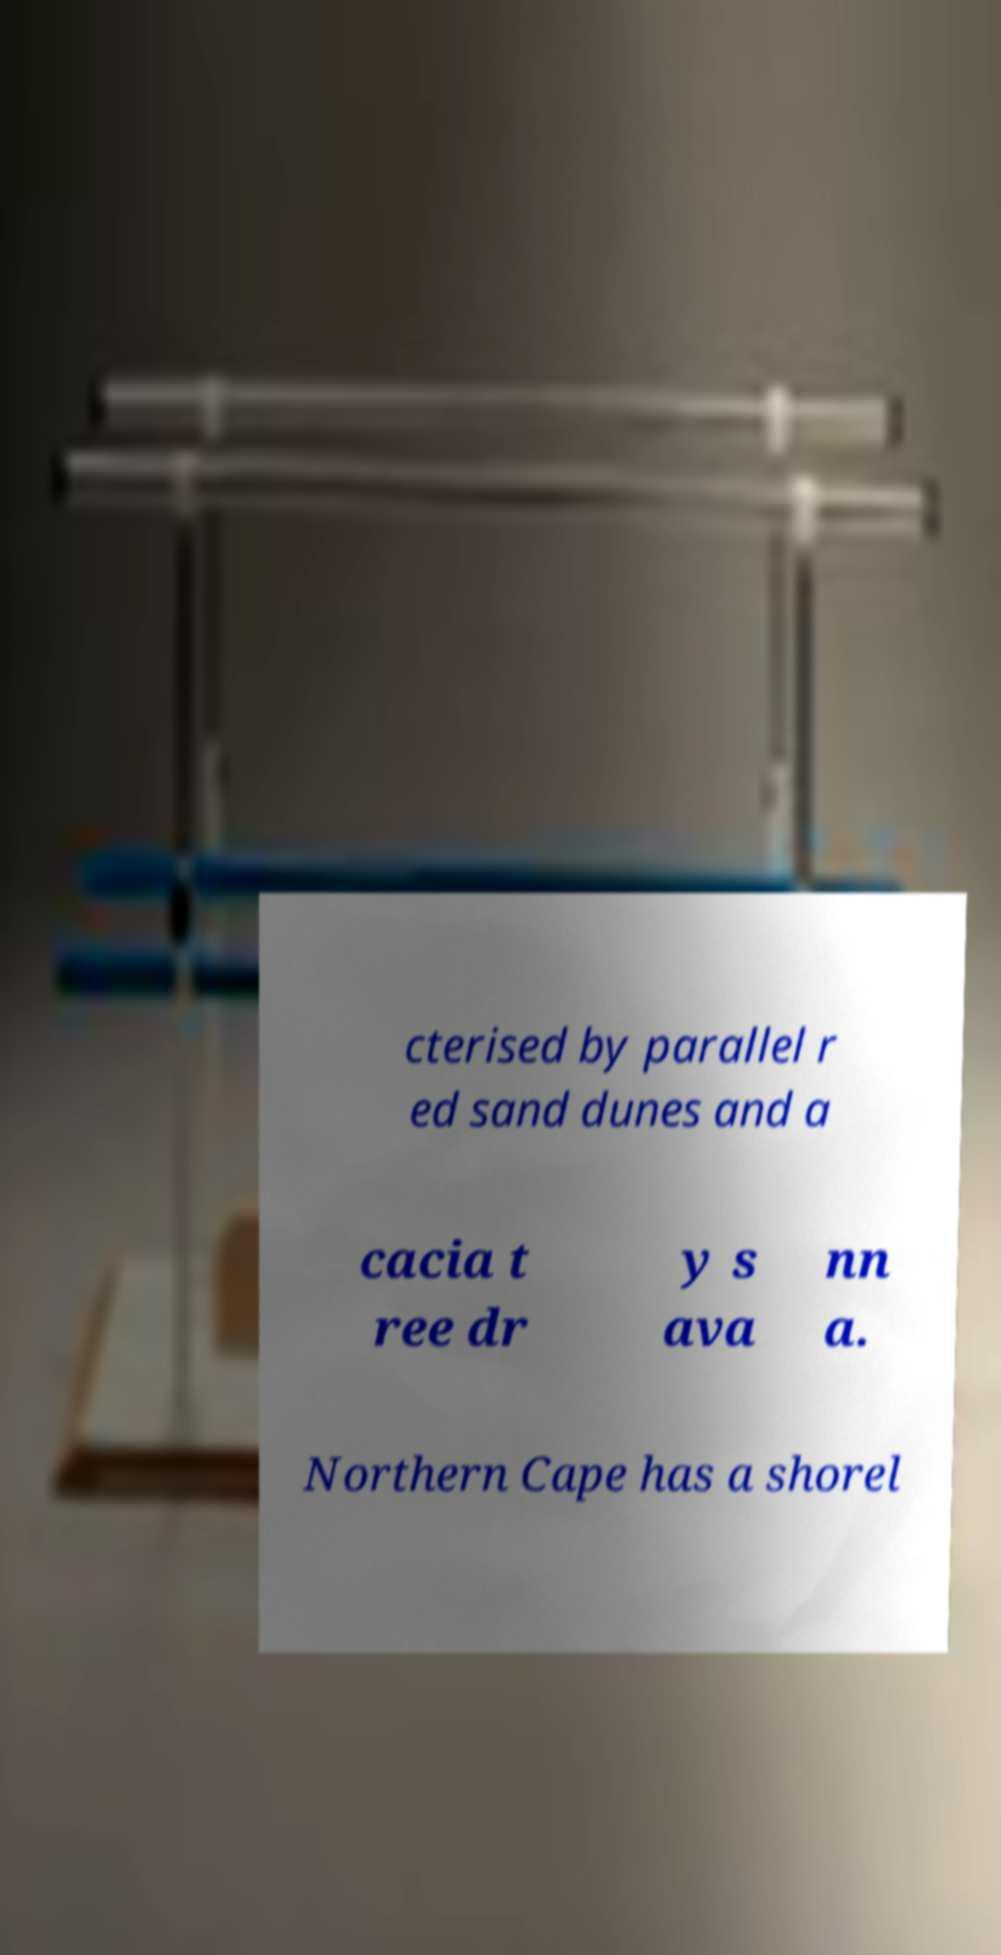Please read and relay the text visible in this image. What does it say? cterised by parallel r ed sand dunes and a cacia t ree dr y s ava nn a. Northern Cape has a shorel 